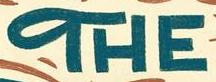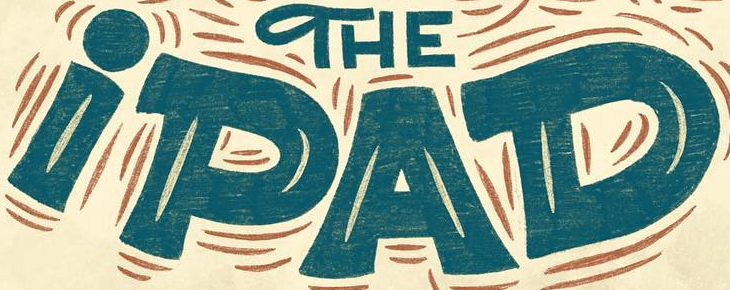Read the text from these images in sequence, separated by a semicolon. THE; iPAD 